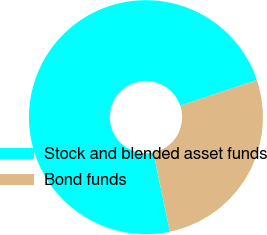Convert chart. <chart><loc_0><loc_0><loc_500><loc_500><pie_chart><fcel>Stock and blended asset funds<fcel>Bond funds<nl><fcel>73.15%<fcel>26.85%<nl></chart> 